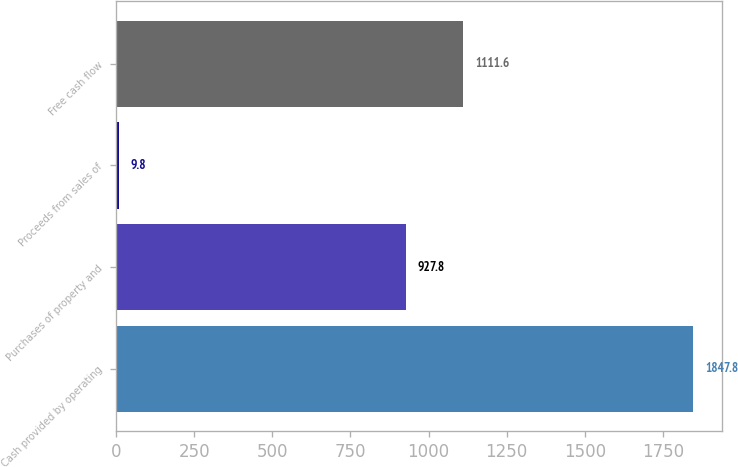Convert chart. <chart><loc_0><loc_0><loc_500><loc_500><bar_chart><fcel>Cash provided by operating<fcel>Purchases of property and<fcel>Proceeds from sales of<fcel>Free cash flow<nl><fcel>1847.8<fcel>927.8<fcel>9.8<fcel>1111.6<nl></chart> 